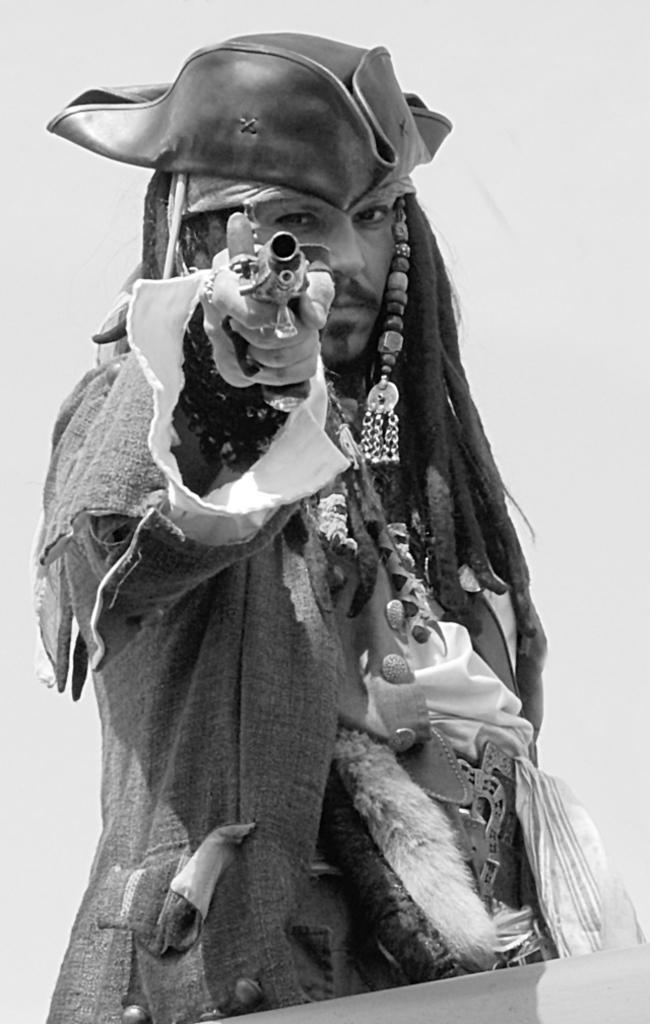How would you summarize this image in a sentence or two? This is a black and white image. There is a person in the middle. He is holding a gun. He is wearing a cap. 